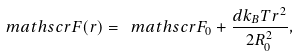Convert formula to latex. <formula><loc_0><loc_0><loc_500><loc_500>\ m a t h s c r { F } ( r ) = \ m a t h s c r { F } _ { 0 } + \frac { d k _ { B } T r ^ { 2 } } { 2 R _ { 0 } ^ { 2 } } ,</formula> 